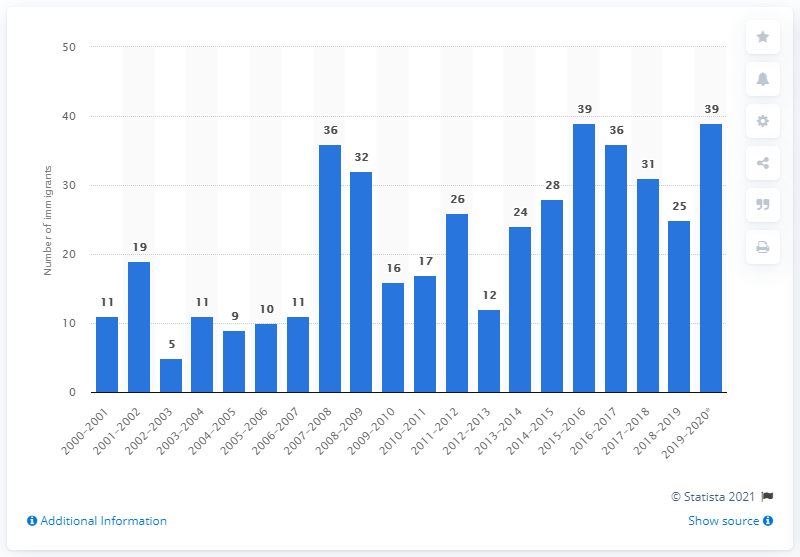Outline some significant characteristics in this image. A total of 39 new immigrants arrived in Nunavut between July 1, 2019 and June 30, 2020. 